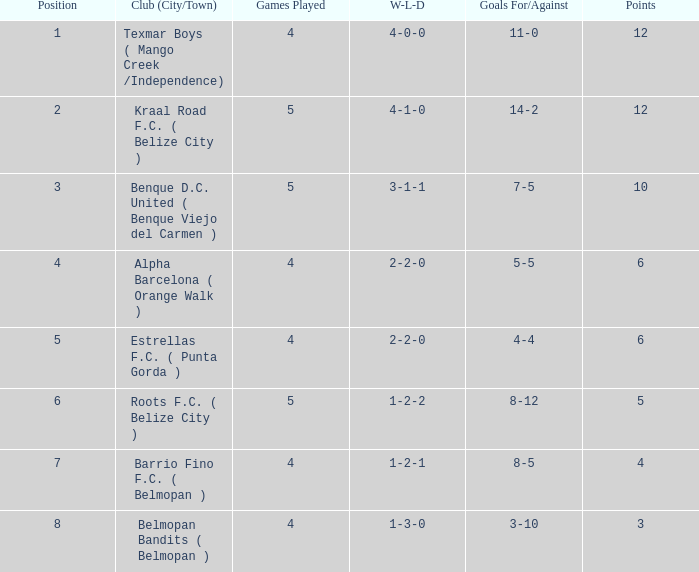What's the w-l-d with position being 1 4-0-0. 